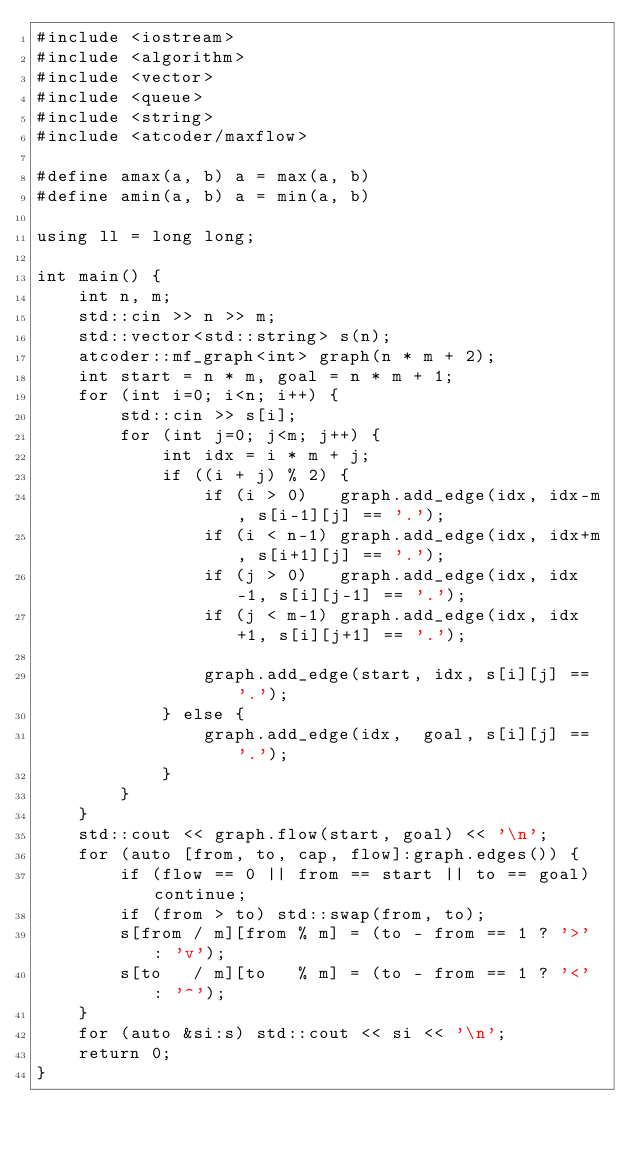<code> <loc_0><loc_0><loc_500><loc_500><_C++_>#include <iostream>
#include <algorithm>
#include <vector>
#include <queue>
#include <string>
#include <atcoder/maxflow>

#define amax(a, b) a = max(a, b)
#define amin(a, b) a = min(a, b)

using ll = long long;

int main() {
    int n, m;
    std::cin >> n >> m;
    std::vector<std::string> s(n);
    atcoder::mf_graph<int> graph(n * m + 2);
    int start = n * m, goal = n * m + 1;
    for (int i=0; i<n; i++) {
        std::cin >> s[i];
        for (int j=0; j<m; j++) {
            int idx = i * m + j;
            if ((i + j) % 2) {
                if (i > 0)   graph.add_edge(idx, idx-m, s[i-1][j] == '.');
                if (i < n-1) graph.add_edge(idx, idx+m, s[i+1][j] == '.');
                if (j > 0)   graph.add_edge(idx, idx-1, s[i][j-1] == '.');
                if (j < m-1) graph.add_edge(idx, idx+1, s[i][j+1] == '.');

                graph.add_edge(start, idx, s[i][j] == '.');
            } else {
                graph.add_edge(idx,  goal, s[i][j] == '.');
            }
        }
    }
    std::cout << graph.flow(start, goal) << '\n';
    for (auto [from, to, cap, flow]:graph.edges()) {
        if (flow == 0 || from == start || to == goal) continue;
        if (from > to) std::swap(from, to);
        s[from / m][from % m] = (to - from == 1 ? '>' : 'v');
        s[to   / m][to   % m] = (to - from == 1 ? '<' : '^');
    }
    for (auto &si:s) std::cout << si << '\n';
    return 0;
}</code> 